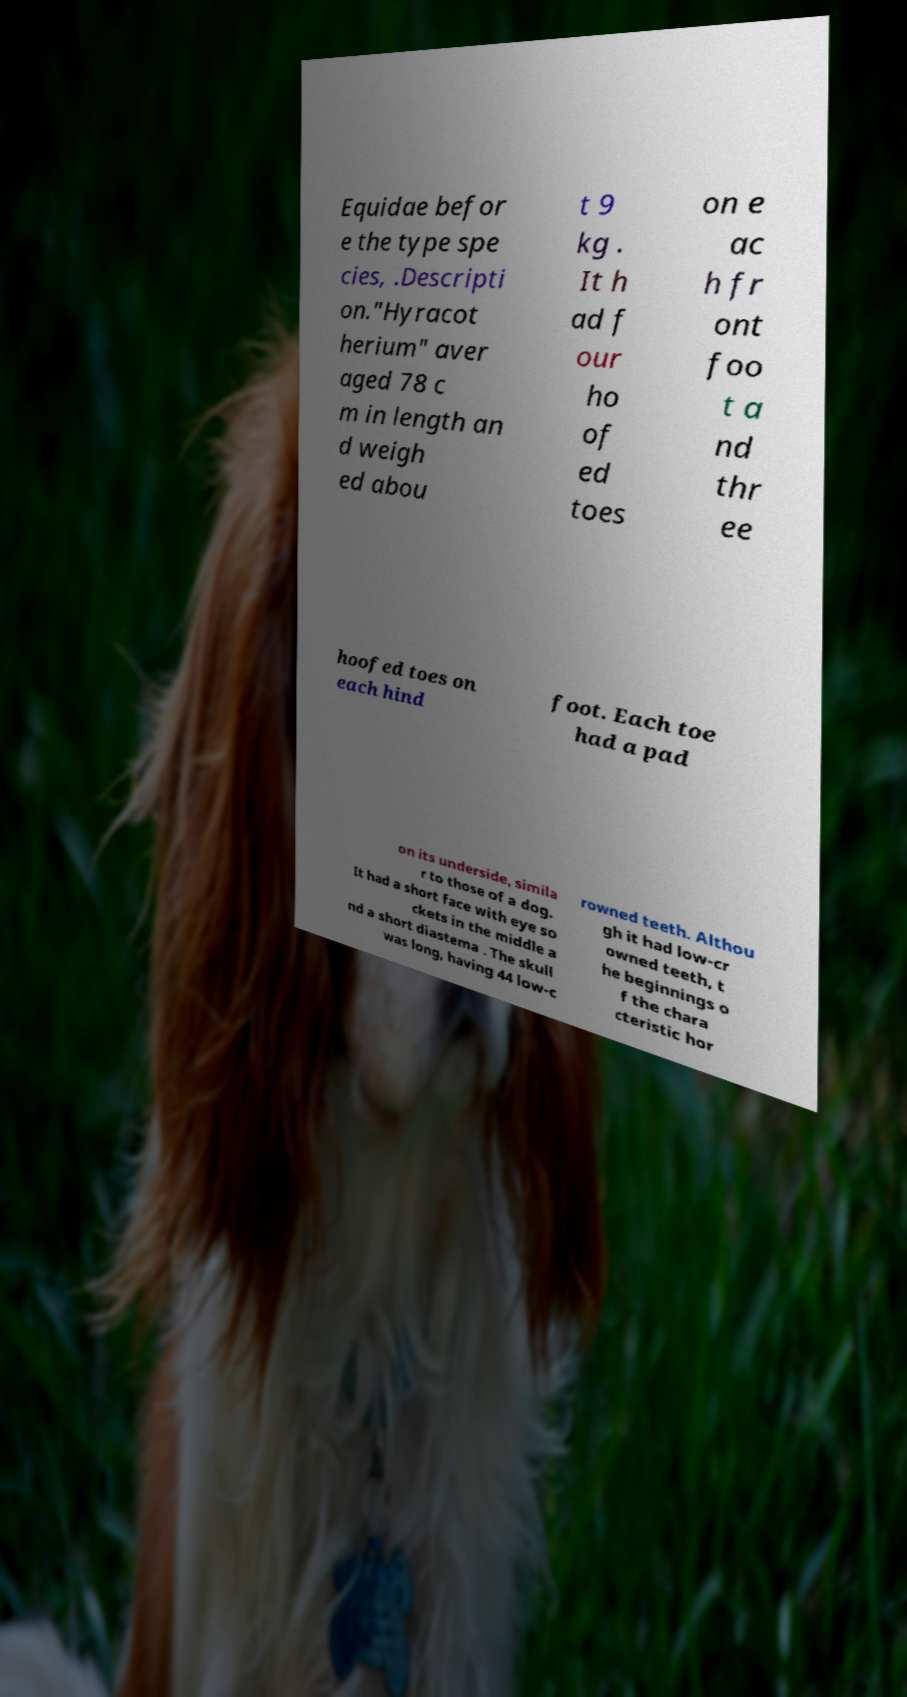What messages or text are displayed in this image? I need them in a readable, typed format. Equidae befor e the type spe cies, .Descripti on."Hyracot herium" aver aged 78 c m in length an d weigh ed abou t 9 kg . It h ad f our ho of ed toes on e ac h fr ont foo t a nd thr ee hoofed toes on each hind foot. Each toe had a pad on its underside, simila r to those of a dog. It had a short face with eye so ckets in the middle a nd a short diastema . The skull was long, having 44 low-c rowned teeth. Althou gh it had low-cr owned teeth, t he beginnings o f the chara cteristic hor 